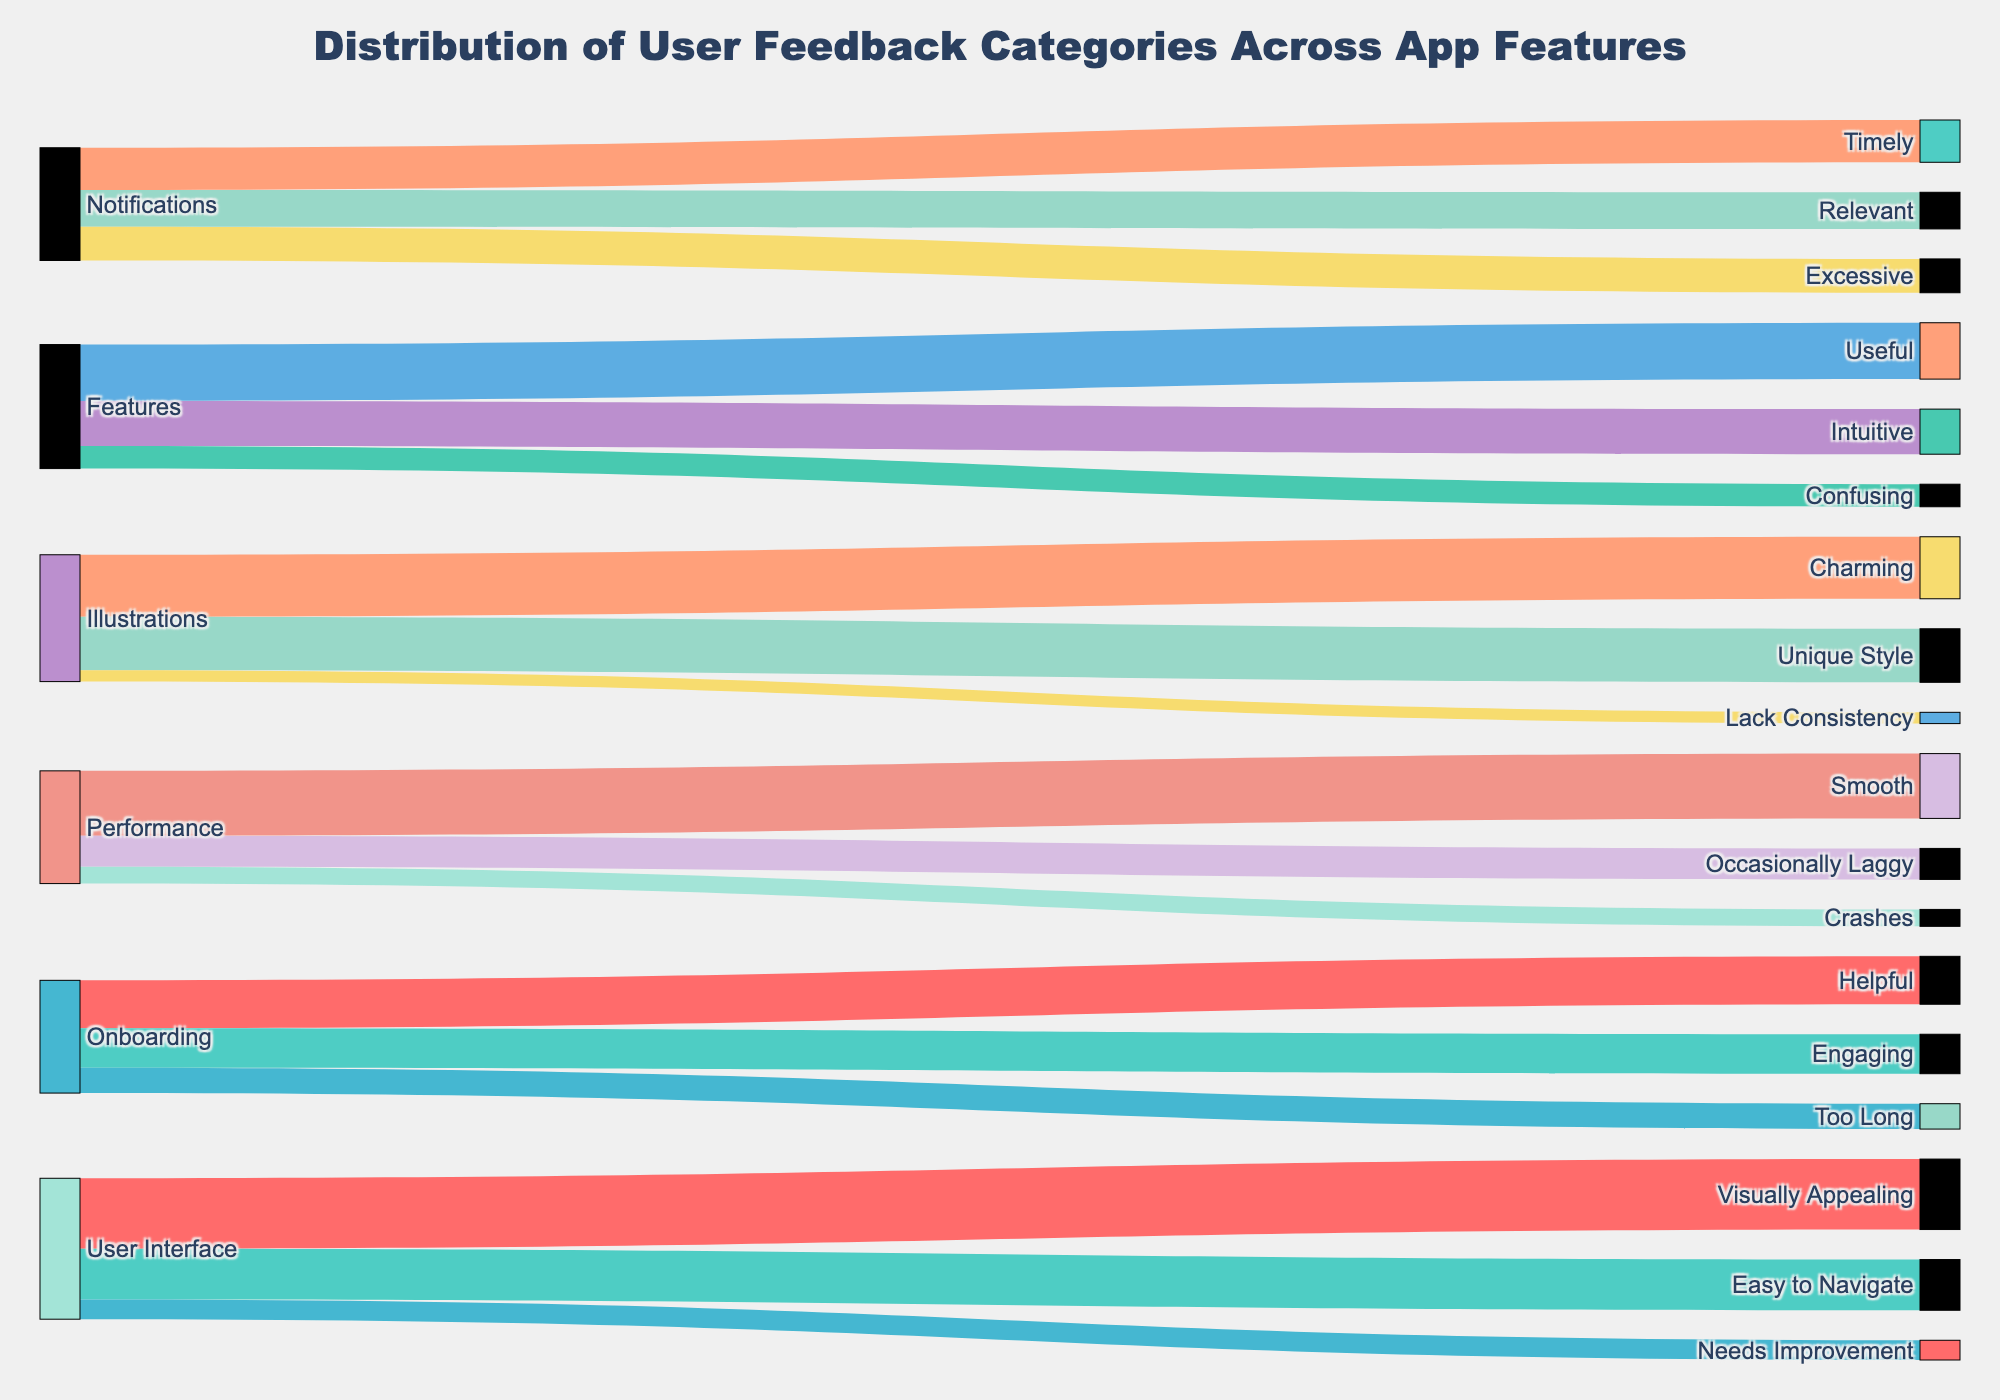What is the title of the figure? The title of the figure is usually the most prominent text displayed at the top of the figure. It describes what the figure is about. Here, the title is "Distribution of User Feedback Categories Across App Features" as indicated in the code.
Answer: Distribution of User Feedback Categories Across App Features Which app feature received the most amount of positive feedback indicating it is "Visually Appealing"? Visual inspection of the Sankey diagram would show the width of the different connections. The connection between "User Interface" and "Visually Appealing" is the widest connection related to being visually appealing, with a value of 250.
Answer: User Interface What feature category has the least complaints for "Needs Improvement"? To find the feature with the least complaints, look at the connections that lead to "Needs Improvement". Here, "User Interface" leads to "Needs Improvement" with a value of 70, which is the only connection with such complaints.
Answer: User Interface How many categories of user feedback are there in total across all app features? By counting the unique target labels in the Sankey diagram, one can determine that there are 18 distinct user feedback categories: Visually Appealing, Easy to Navigate, Needs Improvement, Charming, Unique Style, Lack Consistency, Intuitive, Useful, Confusing, Smooth, Occasionally Laggy, Crashes, Helpful, Engaging, Too Long, Timely, Relevant, and Excessive.
Answer: 18 Which feature received the most feedback for being "Occasionally Laggy"? In the Sankey diagram, the only connection leading to the "Occasionally Laggy" category comes from "Performance" with a value of 110.
Answer: Performance What is the combined total of user feedback for the "Illustrations" feature? Summing up all the values connected to "Illustrations" (Charming: 220, Unique Style: 190, Lack Consistency: 40) gives the total. So, 220 + 190 + 40 = 450.
Answer: 450 